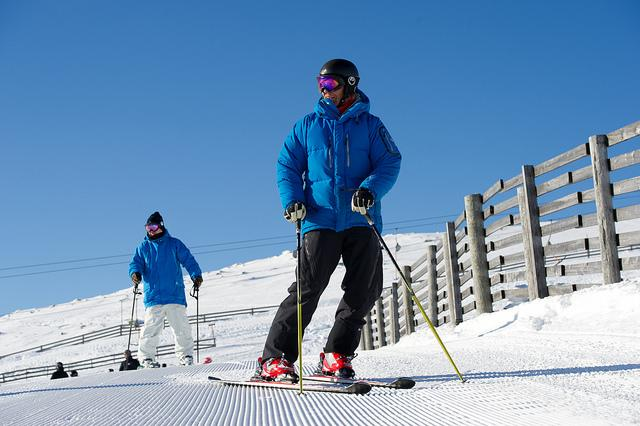What made the grooves seen here?

Choices:
A) skis
B) gophers
C) snow groomer
D) children snow groomer 